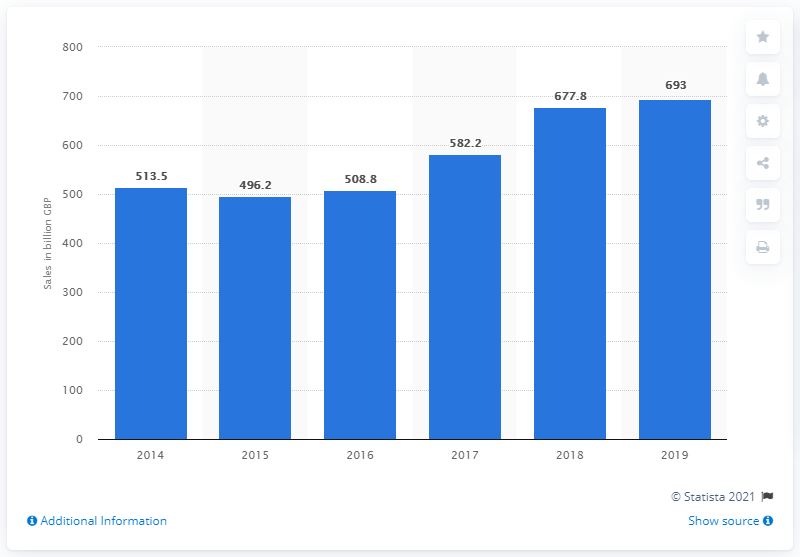Give some essential details in this illustration. In 2019, the value of e-commerce sales in the United Kingdom was approximately 693... 